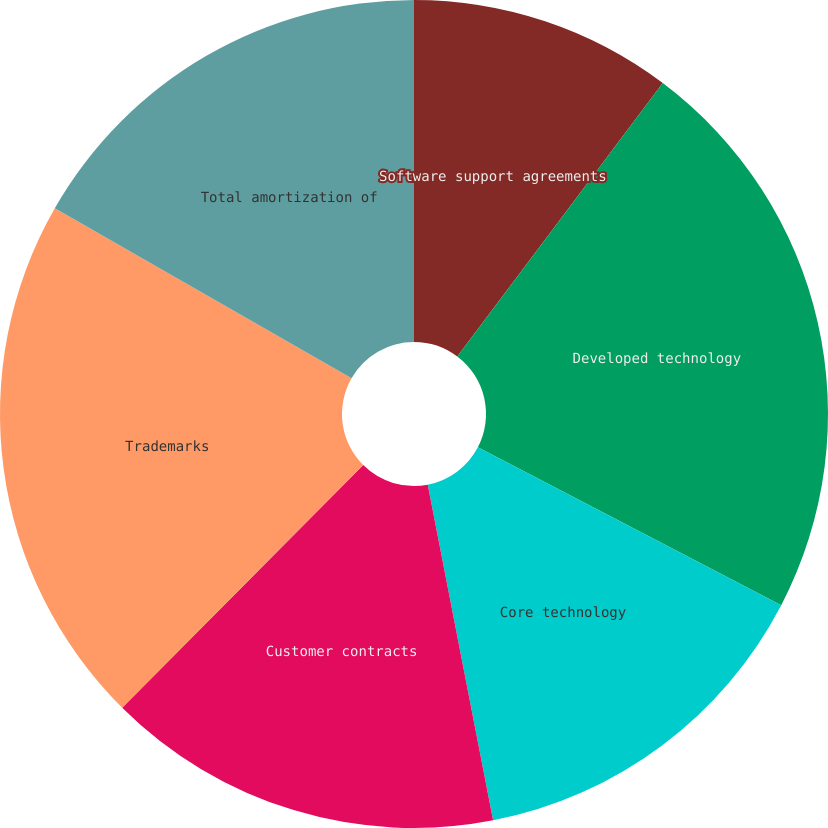Convert chart to OTSL. <chart><loc_0><loc_0><loc_500><loc_500><pie_chart><fcel>Software support agreements<fcel>Developed technology<fcel>Core technology<fcel>Customer contracts<fcel>Trademarks<fcel>Total amortization of<nl><fcel>10.26%<fcel>22.38%<fcel>14.3%<fcel>15.51%<fcel>20.83%<fcel>16.72%<nl></chart> 